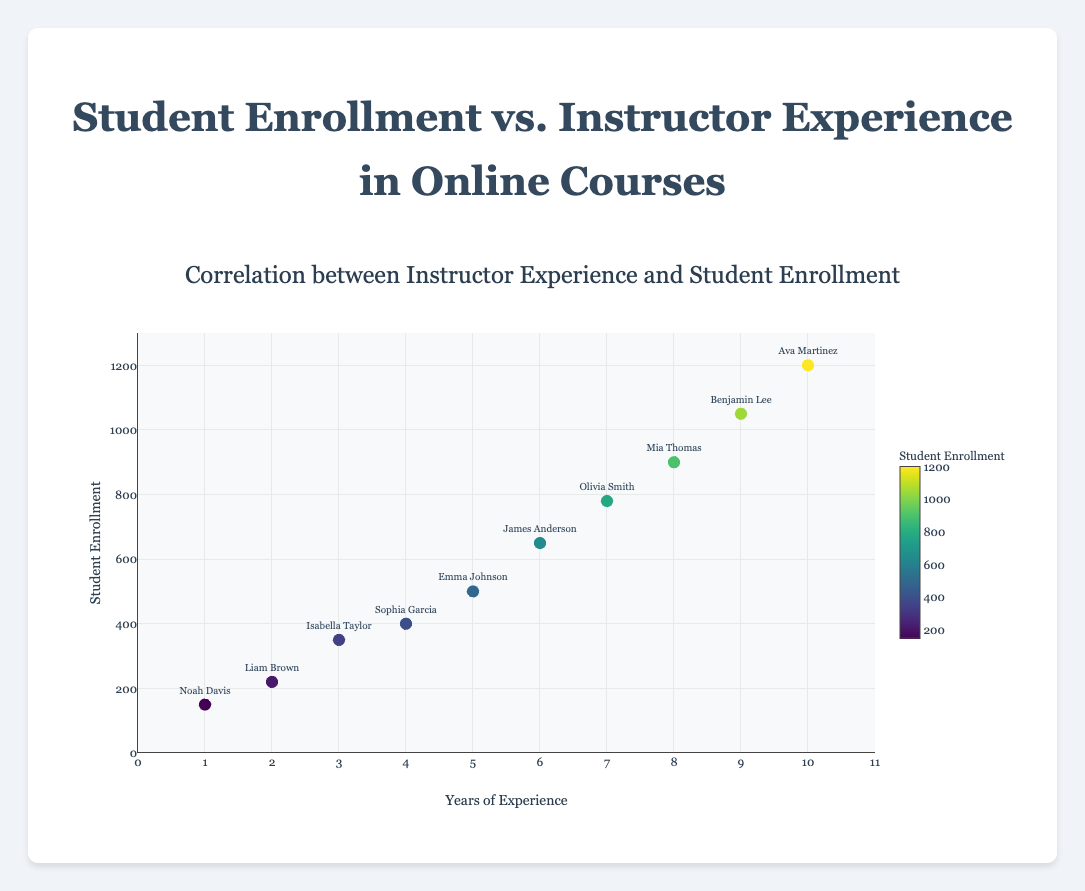How many instructors are displayed in the scatter plot? Count all the data points (instructors) shown in the scatter plot. There are 10 instructors, so we can directly see that there are 10 data points on the plot.
Answer: 10 What is the title of the scatter plot? Locate the title displayed at the top of the scatter plot, which describes the overall context of the figure.
Answer: Correlation between Instructor Experience and Student Enrollment Who has the highest student enrollment, and what is their years of experience? Identify the data point at the highest position on the y-axis and refer to its corresponding text label. The highest student enrollment is for Ava Martinez. From the hover information or the proximity to the x-axis label, she has 10 years of experience.
Answer: Ava Martinez, 10 years What is the average number of student enrollments for instructors with 5 or more years of experience? Identify and sum the student enrollments for Emma Johnson, Olivia Smith, James Anderson, Mia Thomas, Benjamin Lee, and Ava Martinez (500 + 780 + 650 + 900 + 1050 + 1200 = 5080). Divide the total (5080) by the number of instructors (6) to find the average. 5080/6 = 846.67.
Answer: 846.67 Who has the lowest years of experience and what is their student enrollment number? Identify the data point at the farthest left on the x-axis and refer to its corresponding text label. The lowest years of experience is for Noah Davis with 1 year. From the hover information or the y-axis position, his student enrollment is 150.
Answer: Noah Davis, 150 Compare the student enrollment numbers for the instructors with 4 and 5 years of experience. Identify and hover over the data points for 4 years (Sophia Garcia) and 5 years (Emma Johnson). Sophia Garcia has a student enrollment of 400 and Emma Johnson has 500.
Answer: Sophia Garcia: 400, Emma Johnson: 500 What trend can be observed between instructor experience and student enrollment overall? Look for an overall pattern or trend in the scatter plot. Most data points indicate that as the years of experience increase, the student enrollment generally tends to increase.
Answer: Student enrollment tends to increase with more experience Which two instructors are closest to each other in terms of both years of experience and student enrollment? Identify the pairs of data points that are closest to each other in both x-axis (years of experience) and y-axis (student enrollment). James Anderson (6 years, 650 students) and Olivia Smith (7 years, 780 students) are relatively close to each other compared to other pairs.
Answer: James Anderson and Olivia Smith How much more student enrollments does the instructor with the highest experience have compared to the instructor with the least experience? Compare Ava Martinez's student enrollment (1200) and Noah Davis's student enrollment (150) by calculating the difference. 1200 - 150 = 1050.
Answer: 1050 